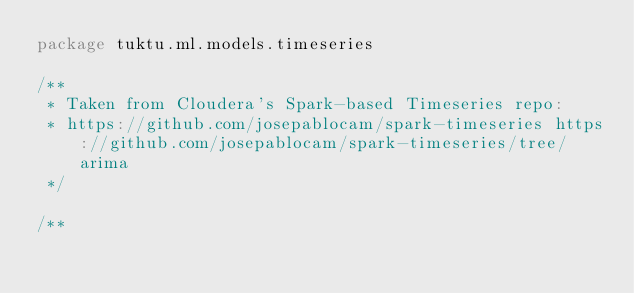Convert code to text. <code><loc_0><loc_0><loc_500><loc_500><_Scala_>package tuktu.ml.models.timeseries

/**
 * Taken from Cloudera's Spark-based Timeseries repo:
 * https://github.com/josepablocam/spark-timeseries https://github.com/josepablocam/spark-timeseries/tree/arima
 */

/**</code> 